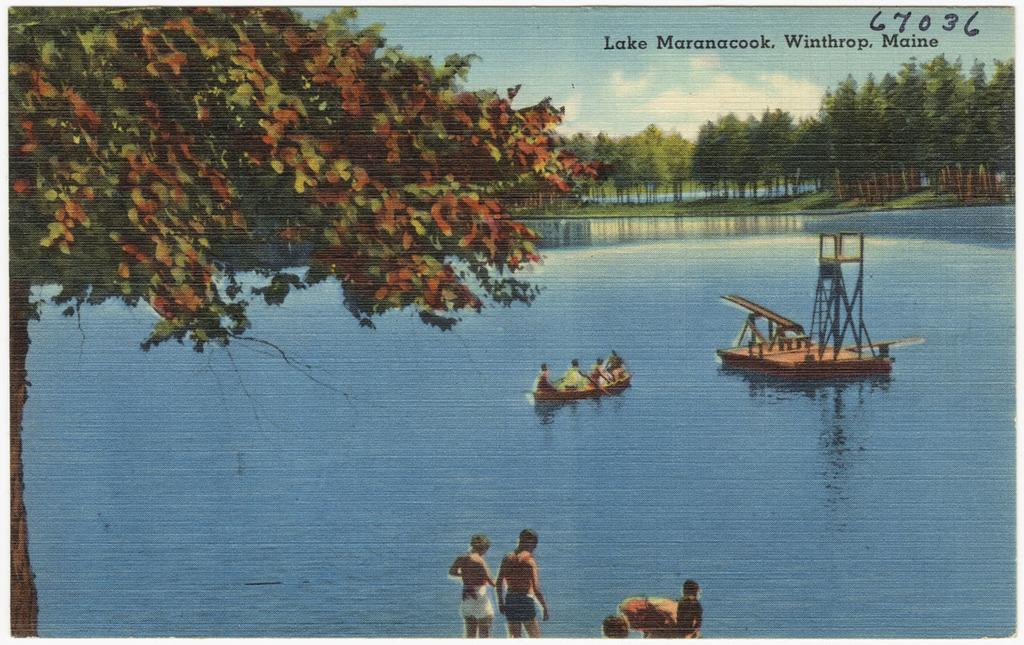What are the people in the image doing? There is a group of people in the water in the image. What else can be seen in the image besides the people? There are two boats, trees, text, grass, and the sky visible in the image. Can you describe the boats in the image? There are two boats in the image, but their specific features cannot be determined from the provided facts. What is the condition of the sky in the image? The sky is visible in the image, but its specific characteristics cannot be determined from the provided facts. How often does the creator cough while editing the image? There is no information about the creator or their actions while editing the image, so this question cannot be answered definitively. 